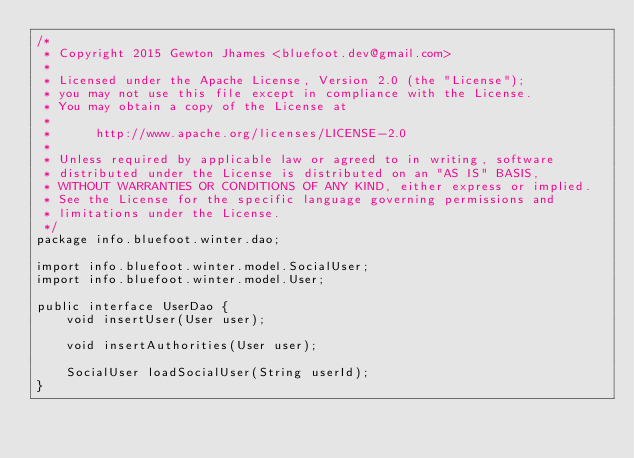<code> <loc_0><loc_0><loc_500><loc_500><_Java_>/*
 * Copyright 2015 Gewton Jhames <bluefoot.dev@gmail.com>
 *
 * Licensed under the Apache License, Version 2.0 (the "License");
 * you may not use this file except in compliance with the License.
 * You may obtain a copy of the License at
 *
 *      http://www.apache.org/licenses/LICENSE-2.0
 *
 * Unless required by applicable law or agreed to in writing, software
 * distributed under the License is distributed on an "AS IS" BASIS,
 * WITHOUT WARRANTIES OR CONDITIONS OF ANY KIND, either express or implied.
 * See the License for the specific language governing permissions and
 * limitations under the License.
 */
package info.bluefoot.winter.dao;

import info.bluefoot.winter.model.SocialUser;
import info.bluefoot.winter.model.User;

public interface UserDao {
    void insertUser(User user);

    void insertAuthorities(User user);

    SocialUser loadSocialUser(String userId);
}
</code> 